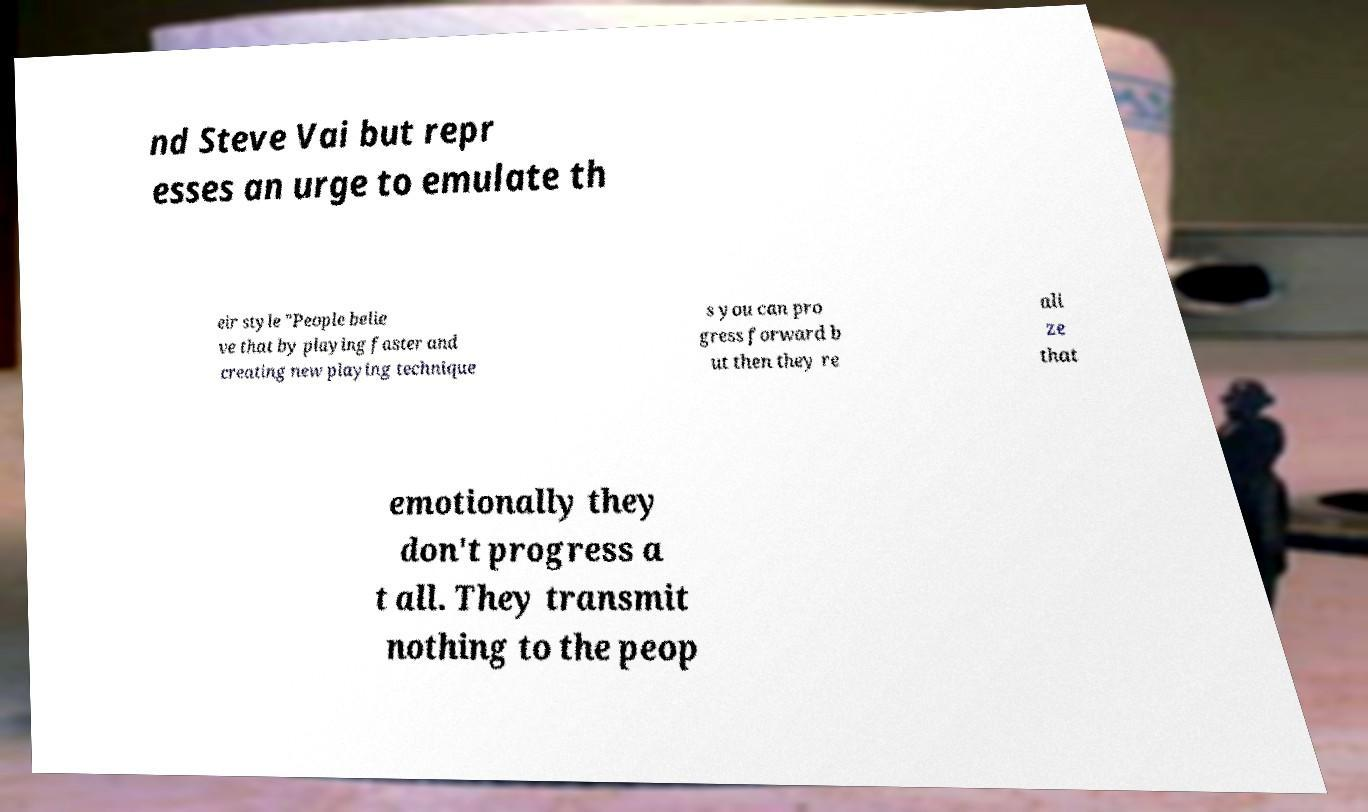Can you read and provide the text displayed in the image?This photo seems to have some interesting text. Can you extract and type it out for me? nd Steve Vai but repr esses an urge to emulate th eir style "People belie ve that by playing faster and creating new playing technique s you can pro gress forward b ut then they re ali ze that emotionally they don't progress a t all. They transmit nothing to the peop 